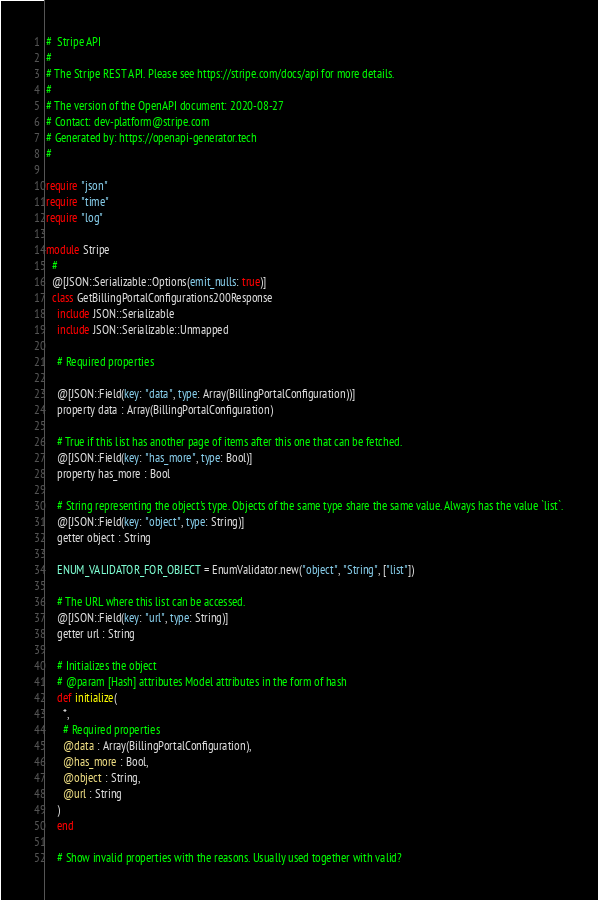Convert code to text. <code><loc_0><loc_0><loc_500><loc_500><_Crystal_>#  Stripe API
#
# The Stripe REST API. Please see https://stripe.com/docs/api for more details.
#
# The version of the OpenAPI document: 2020-08-27
# Contact: dev-platform@stripe.com
# Generated by: https://openapi-generator.tech
#

require "json"
require "time"
require "log"

module Stripe
  #
  @[JSON::Serializable::Options(emit_nulls: true)]
  class GetBillingPortalConfigurations200Response
    include JSON::Serializable
    include JSON::Serializable::Unmapped

    # Required properties

    @[JSON::Field(key: "data", type: Array(BillingPortalConfiguration))]
    property data : Array(BillingPortalConfiguration)

    # True if this list has another page of items after this one that can be fetched.
    @[JSON::Field(key: "has_more", type: Bool)]
    property has_more : Bool

    # String representing the object's type. Objects of the same type share the same value. Always has the value `list`.
    @[JSON::Field(key: "object", type: String)]
    getter object : String

    ENUM_VALIDATOR_FOR_OBJECT = EnumValidator.new("object", "String", ["list"])

    # The URL where this list can be accessed.
    @[JSON::Field(key: "url", type: String)]
    getter url : String

    # Initializes the object
    # @param [Hash] attributes Model attributes in the form of hash
    def initialize(
      *,
      # Required properties
      @data : Array(BillingPortalConfiguration),
      @has_more : Bool,
      @object : String,
      @url : String
    )
    end

    # Show invalid properties with the reasons. Usually used together with valid?</code> 